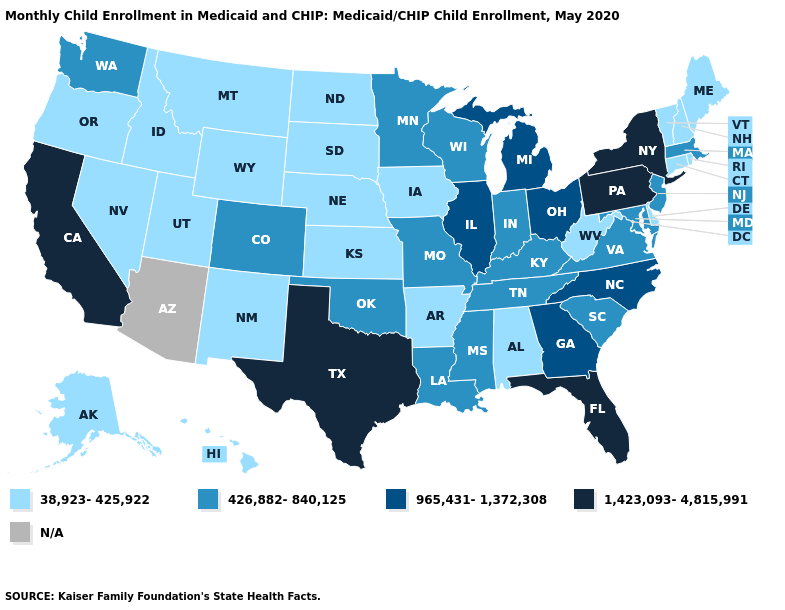Does Missouri have the lowest value in the MidWest?
Concise answer only. No. Name the states that have a value in the range 1,423,093-4,815,991?
Write a very short answer. California, Florida, New York, Pennsylvania, Texas. Which states hav the highest value in the MidWest?
Keep it brief. Illinois, Michigan, Ohio. Does Massachusetts have the lowest value in the Northeast?
Keep it brief. No. What is the value of Missouri?
Short answer required. 426,882-840,125. Which states have the lowest value in the West?
Write a very short answer. Alaska, Hawaii, Idaho, Montana, Nevada, New Mexico, Oregon, Utah, Wyoming. Name the states that have a value in the range N/A?
Answer briefly. Arizona. Among the states that border New Hampshire , does Maine have the highest value?
Be succinct. No. Which states have the lowest value in the South?
Be succinct. Alabama, Arkansas, Delaware, West Virginia. What is the value of Alaska?
Write a very short answer. 38,923-425,922. Among the states that border Florida , which have the highest value?
Keep it brief. Georgia. Which states have the lowest value in the West?
Quick response, please. Alaska, Hawaii, Idaho, Montana, Nevada, New Mexico, Oregon, Utah, Wyoming. Name the states that have a value in the range 426,882-840,125?
Answer briefly. Colorado, Indiana, Kentucky, Louisiana, Maryland, Massachusetts, Minnesota, Mississippi, Missouri, New Jersey, Oklahoma, South Carolina, Tennessee, Virginia, Washington, Wisconsin. Among the states that border New Hampshire , which have the lowest value?
Give a very brief answer. Maine, Vermont. 